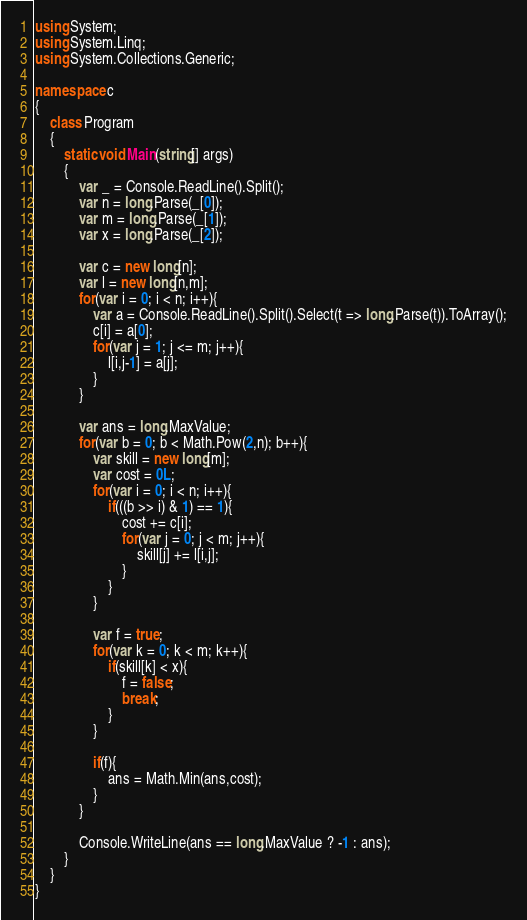Convert code to text. <code><loc_0><loc_0><loc_500><loc_500><_C#_>using System;
using System.Linq;
using System.Collections.Generic;

namespace c
{
    class Program
    {
        static void Main(string[] args)
        {
            var _ = Console.ReadLine().Split();
            var n = long.Parse(_[0]);
            var m = long.Parse(_[1]);
            var x = long.Parse(_[2]);

            var c = new long[n];
            var l = new long[n,m];
            for(var i = 0; i < n; i++){
                var a = Console.ReadLine().Split().Select(t => long.Parse(t)).ToArray();
                c[i] = a[0];
                for(var j = 1; j <= m; j++){
                    l[i,j-1] = a[j];
                }
            }

            var ans = long.MaxValue;
            for(var b = 0; b < Math.Pow(2,n); b++){
                var skill = new long[m];
                var cost = 0L;
                for(var i = 0; i < n; i++){
                    if(((b >> i) & 1) == 1){
                        cost += c[i];
                        for(var j = 0; j < m; j++){
                            skill[j] += l[i,j];
                        }
                    }
                }

                var f = true;
                for(var k = 0; k < m; k++){
                    if(skill[k] < x){
                        f = false;
                        break;
                    }
                }

                if(f){
                    ans = Math.Min(ans,cost);
                }
            }

            Console.WriteLine(ans == long.MaxValue ? -1 : ans);
        }
    }
}
</code> 